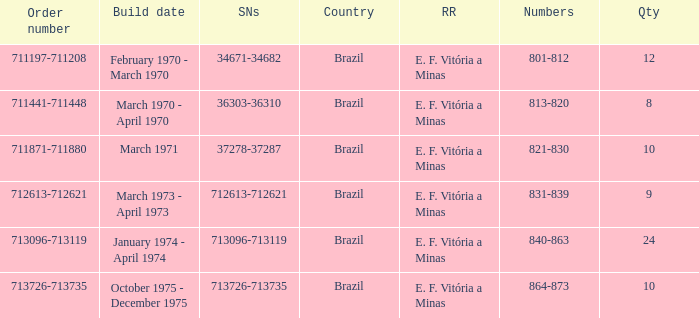The numbers 801-812 are in which country? Brazil. 